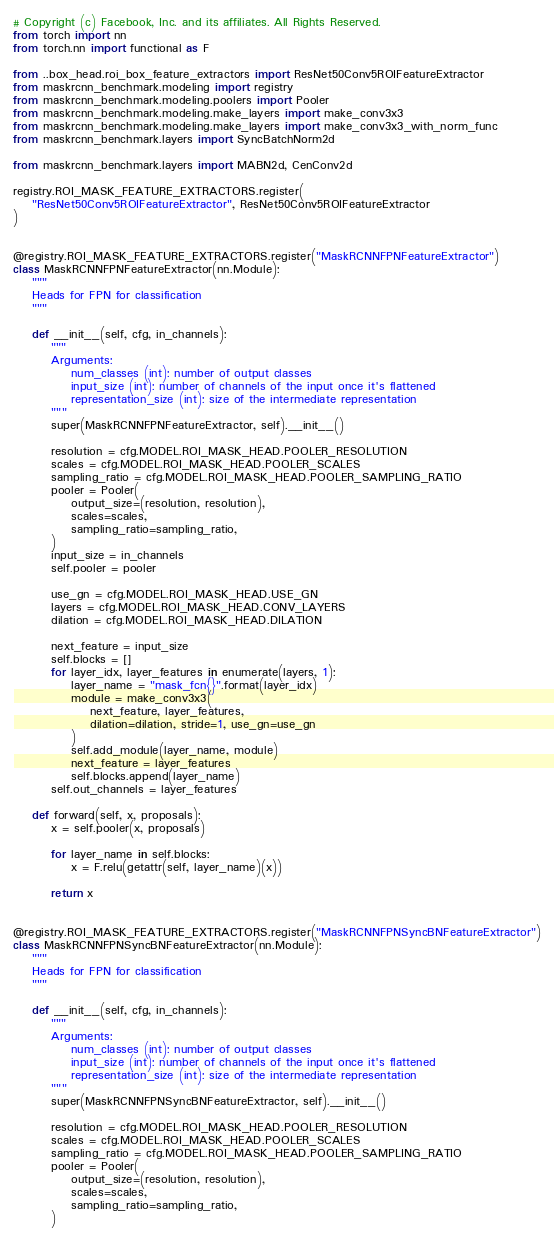Convert code to text. <code><loc_0><loc_0><loc_500><loc_500><_Python_># Copyright (c) Facebook, Inc. and its affiliates. All Rights Reserved.
from torch import nn
from torch.nn import functional as F

from ..box_head.roi_box_feature_extractors import ResNet50Conv5ROIFeatureExtractor
from maskrcnn_benchmark.modeling import registry
from maskrcnn_benchmark.modeling.poolers import Pooler
from maskrcnn_benchmark.modeling.make_layers import make_conv3x3
from maskrcnn_benchmark.modeling.make_layers import make_conv3x3_with_norm_func
from maskrcnn_benchmark.layers import SyncBatchNorm2d

from maskrcnn_benchmark.layers import MABN2d, CenConv2d

registry.ROI_MASK_FEATURE_EXTRACTORS.register(
    "ResNet50Conv5ROIFeatureExtractor", ResNet50Conv5ROIFeatureExtractor
)


@registry.ROI_MASK_FEATURE_EXTRACTORS.register("MaskRCNNFPNFeatureExtractor")
class MaskRCNNFPNFeatureExtractor(nn.Module):
    """
    Heads for FPN for classification
    """

    def __init__(self, cfg, in_channels):
        """
        Arguments:
            num_classes (int): number of output classes
            input_size (int): number of channels of the input once it's flattened
            representation_size (int): size of the intermediate representation
        """
        super(MaskRCNNFPNFeatureExtractor, self).__init__()

        resolution = cfg.MODEL.ROI_MASK_HEAD.POOLER_RESOLUTION
        scales = cfg.MODEL.ROI_MASK_HEAD.POOLER_SCALES
        sampling_ratio = cfg.MODEL.ROI_MASK_HEAD.POOLER_SAMPLING_RATIO
        pooler = Pooler(
            output_size=(resolution, resolution),
            scales=scales,
            sampling_ratio=sampling_ratio,
        )
        input_size = in_channels
        self.pooler = pooler

        use_gn = cfg.MODEL.ROI_MASK_HEAD.USE_GN
        layers = cfg.MODEL.ROI_MASK_HEAD.CONV_LAYERS
        dilation = cfg.MODEL.ROI_MASK_HEAD.DILATION

        next_feature = input_size
        self.blocks = []
        for layer_idx, layer_features in enumerate(layers, 1):
            layer_name = "mask_fcn{}".format(layer_idx)
            module = make_conv3x3(
                next_feature, layer_features,
                dilation=dilation, stride=1, use_gn=use_gn
            )
            self.add_module(layer_name, module)
            next_feature = layer_features
            self.blocks.append(layer_name)
        self.out_channels = layer_features

    def forward(self, x, proposals):
        x = self.pooler(x, proposals)

        for layer_name in self.blocks:
            x = F.relu(getattr(self, layer_name)(x))

        return x


@registry.ROI_MASK_FEATURE_EXTRACTORS.register("MaskRCNNFPNSyncBNFeatureExtractor")
class MaskRCNNFPNSyncBNFeatureExtractor(nn.Module):
    """
    Heads for FPN for classification
    """

    def __init__(self, cfg, in_channels):
        """
        Arguments:
            num_classes (int): number of output classes
            input_size (int): number of channels of the input once it's flattened
            representation_size (int): size of the intermediate representation
        """
        super(MaskRCNNFPNSyncBNFeatureExtractor, self).__init__()

        resolution = cfg.MODEL.ROI_MASK_HEAD.POOLER_RESOLUTION
        scales = cfg.MODEL.ROI_MASK_HEAD.POOLER_SCALES
        sampling_ratio = cfg.MODEL.ROI_MASK_HEAD.POOLER_SAMPLING_RATIO
        pooler = Pooler(
            output_size=(resolution, resolution),
            scales=scales,
            sampling_ratio=sampling_ratio,
        )</code> 